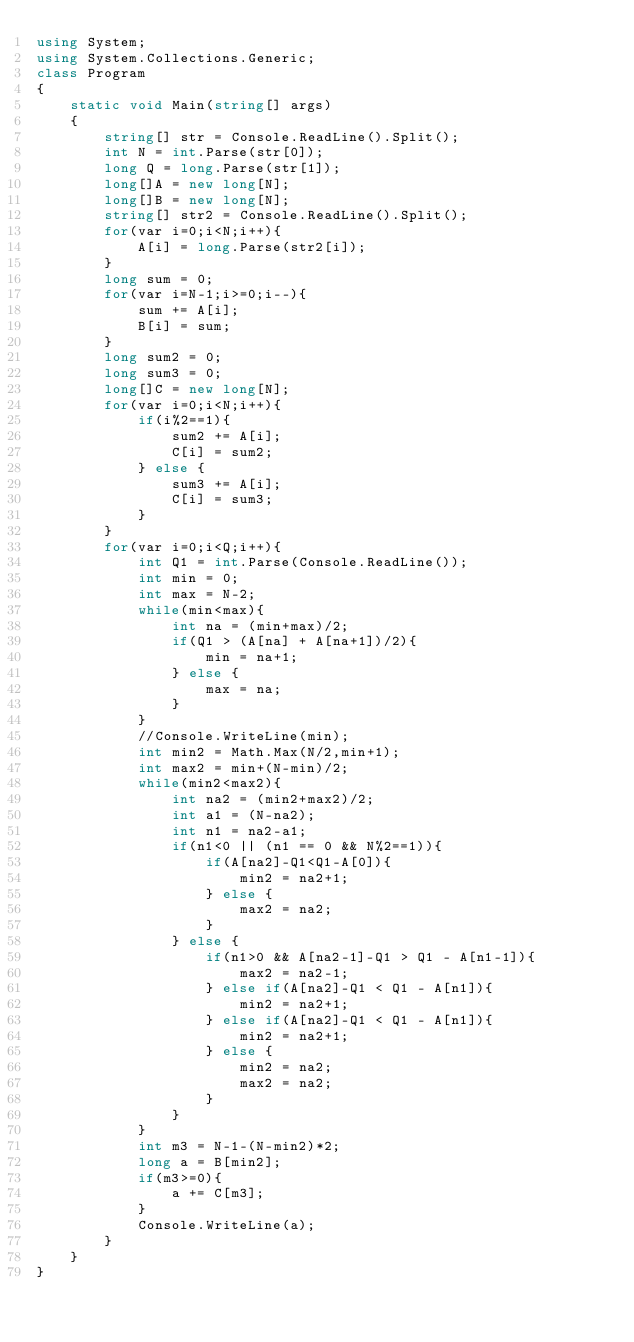<code> <loc_0><loc_0><loc_500><loc_500><_C#_>using System;
using System.Collections.Generic;
class Program
{
	static void Main(string[] args)
	{
		string[] str = Console.ReadLine().Split();
		int N = int.Parse(str[0]);
		long Q = long.Parse(str[1]);
		long[]A = new long[N];
		long[]B = new long[N];
		string[] str2 = Console.ReadLine().Split();
		for(var i=0;i<N;i++){
			A[i] = long.Parse(str2[i]);
		}
		long sum = 0;
		for(var i=N-1;i>=0;i--){
			sum += A[i];
			B[i] = sum;
		}
		long sum2 = 0;
		long sum3 = 0;
		long[]C = new long[N];
		for(var i=0;i<N;i++){
			if(i%2==1){
				sum2 += A[i];
				C[i] = sum2;
			} else {
				sum3 += A[i];
				C[i] = sum3;
			}
		}
		for(var i=0;i<Q;i++){
			int Q1 = int.Parse(Console.ReadLine());
			int min = 0;
			int max = N-2;
			while(min<max){
				int na = (min+max)/2;
				if(Q1 > (A[na] + A[na+1])/2){
					min = na+1;
				} else {
					max = na;
				}
			}
			//Console.WriteLine(min);
			int min2 = Math.Max(N/2,min+1);
			int max2 = min+(N-min)/2;
			while(min2<max2){
				int na2 = (min2+max2)/2;
				int a1 = (N-na2);
				int n1 = na2-a1;
				if(n1<0 || (n1 == 0 && N%2==1)){
					if(A[na2]-Q1<Q1-A[0]){
						min2 = na2+1;
					} else {
						max2 = na2;
					}
				} else {
					if(n1>0 && A[na2-1]-Q1 > Q1 - A[n1-1]){
						max2 = na2-1;
					} else if(A[na2]-Q1 < Q1 - A[n1]){
						min2 = na2+1;
					} else if(A[na2]-Q1 < Q1 - A[n1]){
						min2 = na2+1;
					} else {
						min2 = na2;
						max2 = na2;
					}
				}
			}
			int m3 = N-1-(N-min2)*2;
			long a = B[min2];
			if(m3>=0){
				a += C[m3];
			}
			Console.WriteLine(a);
		}
	}
}</code> 